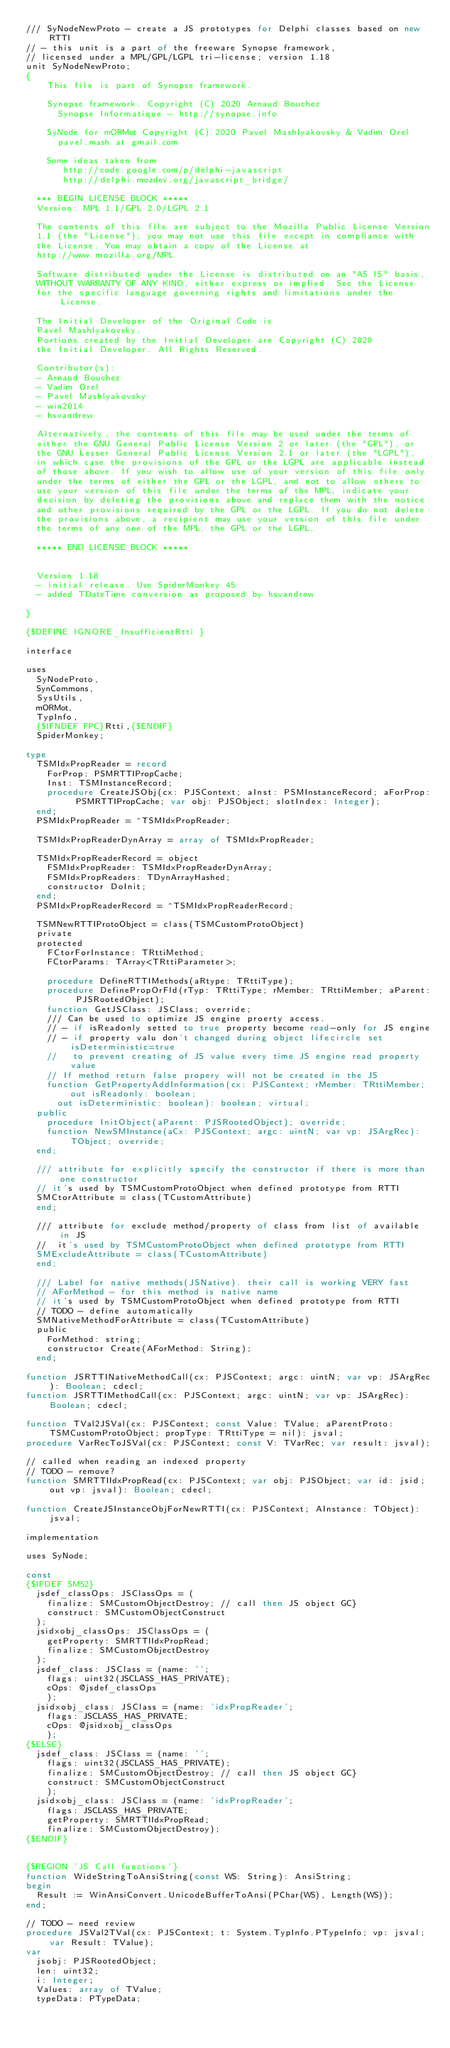<code> <loc_0><loc_0><loc_500><loc_500><_Pascal_>/// SyNodeNewProto - create a JS prototypes for Delphi classes based on new RTTI
// - this unit is a part of the freeware Synopse framework,
// licensed under a MPL/GPL/LGPL tri-license; version 1.18
unit SyNodeNewProto;
{
    This file is part of Synopse framework.

    Synopse framework. Copyright (C) 2020 Arnaud Bouchez
      Synopse Informatique - http://synopse.info

    SyNode for mORMot Copyright (C) 2020 Pavel Mashlyakovsky & Vadim Orel
      pavel.mash at gmail.com

    Some ideas taken from
       http://code.google.com/p/delphi-javascript
       http://delphi.mozdev.org/javascript_bridge/

  *** BEGIN LICENSE BLOCK *****
  Version: MPL 1.1/GPL 2.0/LGPL 2.1

  The contents of this file are subject to the Mozilla Public License Version
  1.1 (the "License"); you may not use this file except in compliance with
  the License. You may obtain a copy of the License at
  http://www.mozilla.org/MPL

  Software distributed under the License is distributed on an "AS IS" basis,
  WITHOUT WARRANTY OF ANY KIND, either express or implied. See the License
  for the specific language governing rights and limitations under the License.

  The Initial Developer of the Original Code is
  Pavel Mashlyakovsky.
  Portions created by the Initial Developer are Copyright (C) 2020
  the Initial Developer. All Rights Reserved.

  Contributor(s):
  - Arnaud Bouchez
  - Vadim Orel
  - Pavel Mashlyakovsky
  - win2014
  - hsvandrew

  Alternatively, the contents of this file may be used under the terms of
  either the GNU General Public License Version 2 or later (the "GPL"), or
  the GNU Lesser General Public License Version 2.1 or later (the "LGPL"),
  in which case the provisions of the GPL or the LGPL are applicable instead
  of those above. If you wish to allow use of your version of this file only
  under the terms of either the GPL or the LGPL, and not to allow others to
  use your version of this file under the terms of the MPL, indicate your
  decision by deleting the provisions above and replace them with the notice
  and other provisions required by the GPL or the LGPL. If you do not delete
  the provisions above, a recipient may use your version of this file under
  the terms of any one of the MPL, the GPL or the LGPL.

  ***** END LICENSE BLOCK *****


  Version 1.18
  - initial release. Use SpiderMonkey 45
  - added TDateTime conversion as proposed by hsvandrew

}

{$DEFINE IGNORE_InsufficientRtti }

interface

uses
  SyNodeProto,
  SynCommons,
  SysUtils,
  mORMot,
  TypInfo,
  {$IFNDEF FPC}Rtti,{$ENDIF}
  SpiderMonkey;

type
  TSMIdxPropReader = record
    ForProp: PSMRTTIPropCache;
    Inst: TSMInstanceRecord;
    procedure CreateJSObj(cx: PJSContext; aInst: PSMInstanceRecord; aForProp: PSMRTTIPropCache; var obj: PJSObject; slotIndex: Integer);
  end;
  PSMIdxPropReader = ^TSMIdxPropReader;

  TSMIdxPropReaderDynArray = array of TSMIdxPropReader;

  TSMIdxPropReaderRecord = object
    FSMIdxPropReader: TSMIdxPropReaderDynArray;
    FSMIdxPropReaders: TDynArrayHashed;
    constructor DoInit;
  end;
  PSMIdxPropReaderRecord = ^TSMIdxPropReaderRecord;

  TSMNewRTTIProtoObject = class(TSMCustomProtoObject)
  private
  protected
    FCtorForInstance: TRttiMethod;
    FCtorParams: TArray<TRttiParameter>;

    procedure DefineRTTIMethods(aRtype: TRttiType);
    procedure DefinePropOrFld(rTyp: TRttiType; rMember: TRttiMember; aParent: PJSRootedObject);
    function GetJSClass: JSClass; override;
    /// Can be used to optimize JS engine proerty access.
    // - if isReadonly setted to true property become read-only for JS engine
    // - if property valu don't changed during object lifecircle set isDeterministic=true
    //   to prevent creating of JS value every time JS engine read property value
    // If method return false propery will not be created in the JS
    function GetPropertyAddInformation(cx: PJSContext; rMember: TRttiMember; out isReadonly: boolean;
      out isDeterministic: boolean): boolean; virtual;
  public
    procedure InitObject(aParent: PJSRootedObject); override;
    function NewSMInstance(aCx: PJSContext; argc: uintN; var vp: JSArgRec): TObject; override;
  end;

  /// attribute for explicitly specify the constructor if there is more than one constructor
  // it's used by TSMCustomProtoObject when defined prototype from RTTI
  SMCtorAttribute = class(TCustomAttribute)
  end;

  /// attribute for exclude method/property of class from list of available in JS
  //  it's used by TSMCustomProtoObject when defined prototype from RTTI
  SMExcludeAttribute = class(TCustomAttribute)
  end;

  /// Label for native methods(JSNative). their call is working VERY fast
  // AForMethod - for this method is native name
  // it's used by TSMCustomProtoObject when defined prototype from RTTI
  // TODO - define automatically
  SMNativeMethodForAttribute = class(TCustomAttribute)
  public
    ForMethod: string;
    constructor Create(AForMethod: String);
  end;

function JSRTTINativeMethodCall(cx: PJSContext; argc: uintN; var vp: JSArgRec): Boolean; cdecl;
function JSRTTIMethodCall(cx: PJSContext; argc: uintN; var vp: JSArgRec): Boolean; cdecl;

function TVal2JSVal(cx: PJSContext; const Value: TValue; aParentProto: TSMCustomProtoObject; propType: TRttiType = nil): jsval;
procedure VarRecToJSVal(cx: PJSContext; const V: TVarRec; var result: jsval);

// called when reading an indexed property
// TODO - remove?
function SMRTTIIdxPropRead(cx: PJSContext; var obj: PJSObject; var id: jsid; out vp: jsval): Boolean; cdecl;

function CreateJSInstanceObjForNewRTTI(cx: PJSContext; AInstance: TObject): jsval;

implementation

uses SyNode;

const
{$IFDEF SM52}
  jsdef_classOps: JSClassOps = (
    finalize: SMCustomObjectDestroy; // call then JS object GC}
    construct: SMCustomObjectConstruct
  );
  jsidxobj_classOps: JSClassOps = (
    getProperty: SMRTTIIdxPropRead;
    finalize: SMCustomObjectDestroy
  );
  jsdef_class: JSClass = (name: '';
    flags: uint32(JSCLASS_HAS_PRIVATE);
    cOps: @jsdef_classOps
    );
  jsidxobj_class: JSClass = (name: 'idxPropReader';
    flags: JSCLASS_HAS_PRIVATE;
    cOps: @jsidxobj_classOps
    );
{$ELSE}
  jsdef_class: JSClass = (name: '';
    flags: uint32(JSCLASS_HAS_PRIVATE);
    finalize: SMCustomObjectDestroy; // call then JS object GC}
    construct: SMCustomObjectConstruct
    );
  jsidxobj_class: JSClass = (name: 'idxPropReader';
    flags: JSCLASS_HAS_PRIVATE;
    getProperty: SMRTTIIdxPropRead;
    finalize: SMCustomObjectDestroy);
{$ENDIF}


{$REGION 'JS Call functions'}
function WideStringToAnsiString(const WS: String): AnsiString;
begin
  Result := WinAnsiConvert.UnicodeBufferToAnsi(PChar(WS), Length(WS));
end;

// TODO - need review
procedure JSVal2TVal(cx: PJSContext; t: System.TypInfo.PTypeInfo; vp: jsval; var Result: TValue);
var
  jsobj: PJSRootedObject;
  len: uint32;
  i: Integer;
  Values: array of TValue;
  typeData: PTypeData;</code> 